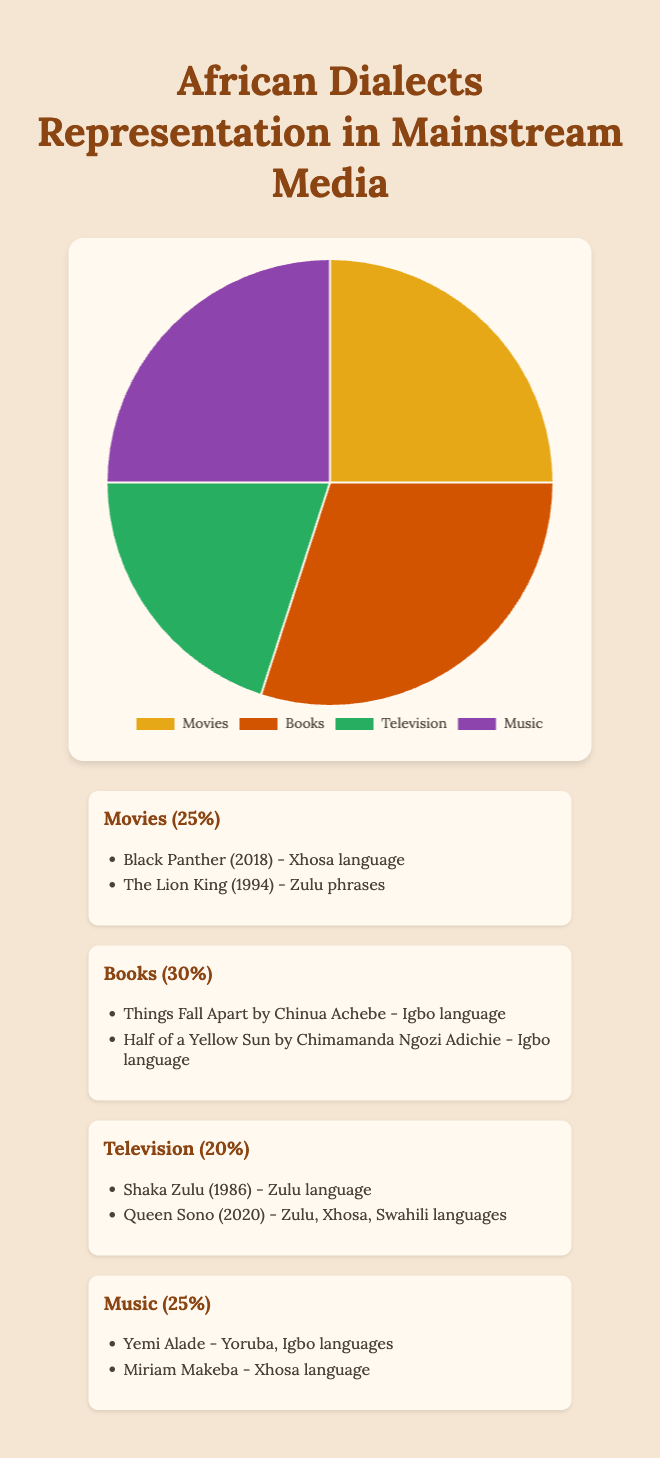Which category has the highest percentage of African dialect representation? By observing the pie chart, "Books" have the largest portion, which is 30%.
Answer: Books What is the combined percentage of African dialect representation in Movies and Music? Adding the percentages for Movies (25%) and Music (25%) gives a total of 25 + 25 = 50%.
Answer: 50% Is there an equal representation of African dialects in any two categories? By examining the chart, "Movies" and "Music" both have the same percentage of 25%.
Answer: Yes, Movies and Music How much larger is the representation of African dialects in Books compared to Television? The percentage for Books is 30% and for Television is 20%. The difference is 30 - 20 = 10%.
Answer: 10% Which category has the smallest representation of African dialects? By inspecting the pie chart, "Television" has the smallest portion at 20%.
Answer: Television What is the average percentage representation of African dialects in all categories? Summing up the percentages (25 + 30 + 20 + 25) gives 100. Dividing by the number of categories (4) results in 100 / 4 = 25%.
Answer: 25% Is the representation of African dialects in Movies more than in Television? Comparing the two, Movies (25%) is more than Television (20%).
Answer: Yes What color is used to represent Books in the pie chart? Reviewing the visual attributes, Books are represented by the color similar to burnt orange.
Answer: Burnt orange What’s the difference in percentage representation between the category with the highest and the category with the lowest African dialect representation? The highest is Books (30%) and the lowest is Television (20%). The difference is 30 - 20 = 10%.
Answer: 10% How much of the pie chart does the Music category occupy? Observing the chart, Music occupies a quarter or 25% of the chart.
Answer: 25% 